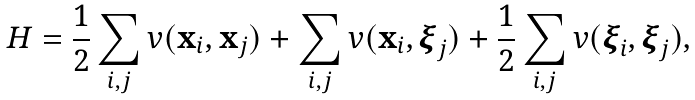<formula> <loc_0><loc_0><loc_500><loc_500>H = \frac { 1 } { 2 } \sum _ { i , j } v ( { \mathbf x } _ { i } , { \mathbf x } _ { j } ) + \sum _ { i , j } v ( { \mathbf x } _ { i } , { \boldsymbol \xi } _ { j } ) + \frac { 1 } { 2 } \sum _ { i , j } v ( { \boldsymbol \xi } _ { i } , { \boldsymbol \xi } _ { j } ) ,</formula> 